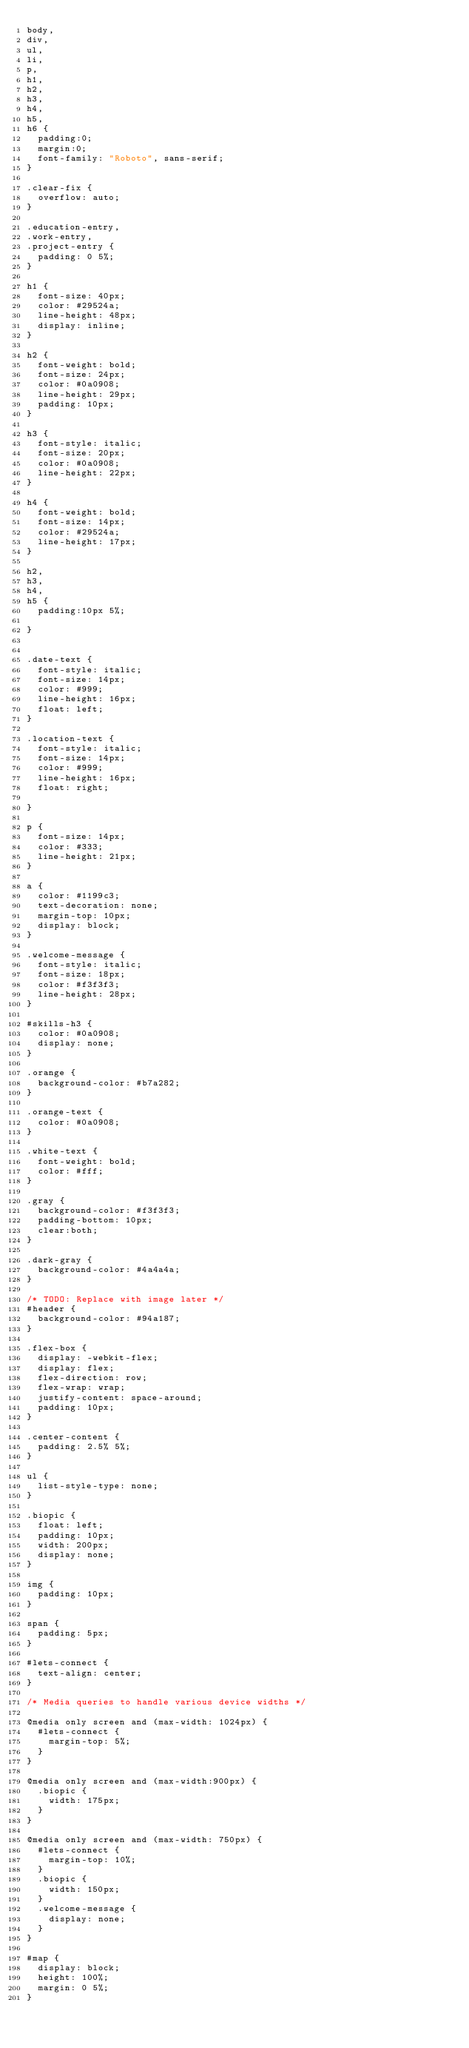Convert code to text. <code><loc_0><loc_0><loc_500><loc_500><_CSS_>body,
div,
ul,
li,
p,
h1,
h2,
h3,
h4,
h5,
h6 {
  padding:0;
  margin:0;
  font-family: "Roboto", sans-serif;
}

.clear-fix {
  overflow: auto;
}

.education-entry,
.work-entry,
.project-entry {
  padding: 0 5%;
}

h1 {
  font-size: 40px;
  color: #29524a;
  line-height: 48px;
  display: inline;
}

h2 {
  font-weight: bold;
  font-size: 24px;
  color: #0a0908;
  line-height: 29px;
  padding: 10px;
}

h3 {
  font-style: italic;
  font-size: 20px;
  color: #0a0908;
  line-height: 22px;
}

h4 {
  font-weight: bold;
  font-size: 14px;
  color: #29524a;
  line-height: 17px;
}

h2,
h3,
h4,
h5 {
  padding:10px 5%;

}


.date-text {
  font-style: italic;
  font-size: 14px;
  color: #999;
  line-height: 16px;
  float: left;
}

.location-text {
  font-style: italic;
  font-size: 14px;
  color: #999;
  line-height: 16px;
  float: right;

}

p {
  font-size: 14px;
  color: #333;
  line-height: 21px;
}

a {
  color: #1199c3;
  text-decoration: none;
  margin-top: 10px;
  display: block;
}

.welcome-message {
  font-style: italic;
  font-size: 18px;
  color: #f3f3f3;
  line-height: 28px;
}

#skills-h3 {
  color: #0a0908;
  display: none;
}

.orange {
  background-color: #b7a282;
}

.orange-text {
  color: #0a0908;
}

.white-text {
  font-weight: bold;
  color: #fff;
}

.gray {
  background-color: #f3f3f3;
  padding-bottom: 10px;
  clear:both;
}

.dark-gray {
  background-color: #4a4a4a;
}

/* TODO: Replace with image later */
#header {
  background-color: #94a187;
}

.flex-box {
  display: -webkit-flex;
  display: flex;
  flex-direction: row;
  flex-wrap: wrap;
  justify-content: space-around;
  padding: 10px;
}

.center-content {
  padding: 2.5% 5%;
}

ul {
  list-style-type: none;
}

.biopic {
  float: left;
  padding: 10px;
  width: 200px;
  display: none;
}

img {
  padding: 10px;
}

span {
  padding: 5px;
}

#lets-connect {
  text-align: center;
}

/* Media queries to handle various device widths */

@media only screen and (max-width: 1024px) {
  #lets-connect {
    margin-top: 5%;
  }
}

@media only screen and (max-width:900px) {
  .biopic {
    width: 175px;
  }
}

@media only screen and (max-width: 750px) {
  #lets-connect {
    margin-top: 10%;
  }
  .biopic {
    width: 150px;
  }
  .welcome-message {
    display: none;
  }
}

#map {
  display: block;
  height: 100%;
  margin: 0 5%;
}
</code> 